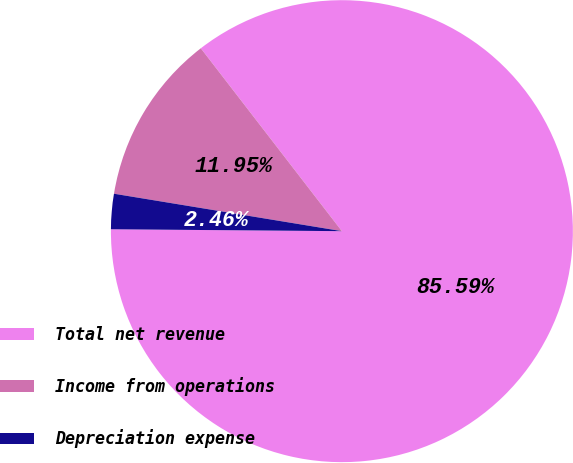<chart> <loc_0><loc_0><loc_500><loc_500><pie_chart><fcel>Total net revenue<fcel>Income from operations<fcel>Depreciation expense<nl><fcel>85.59%<fcel>11.95%<fcel>2.46%<nl></chart> 